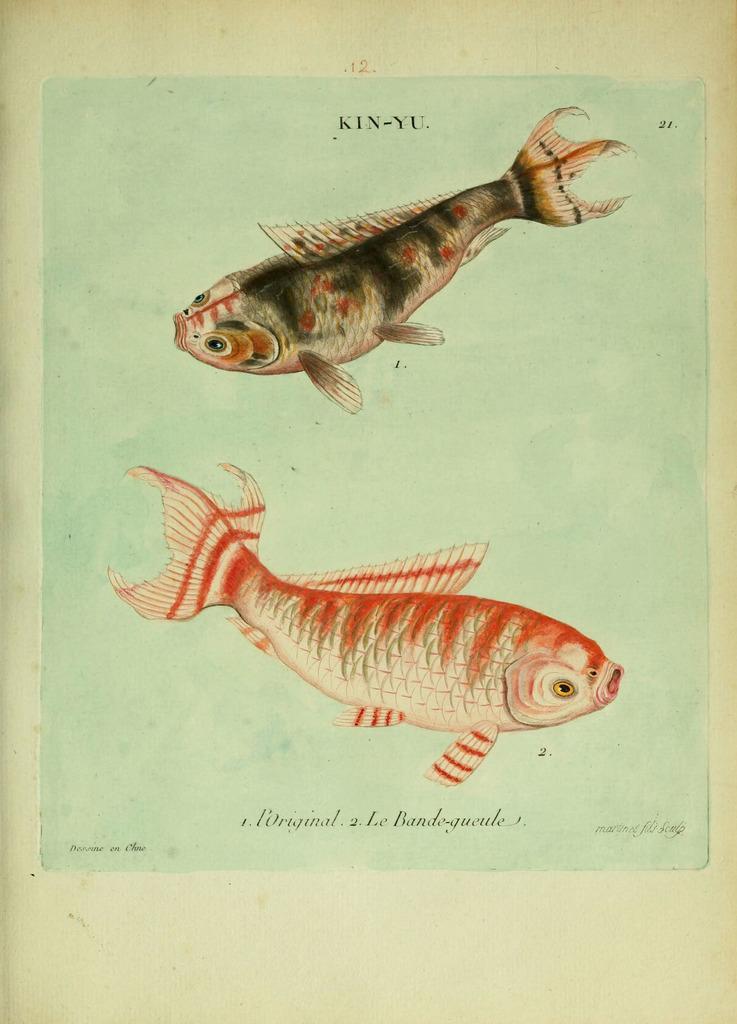In one or two sentences, can you explain what this image depicts? This is a painting and here we can see fishes and there is some text. 